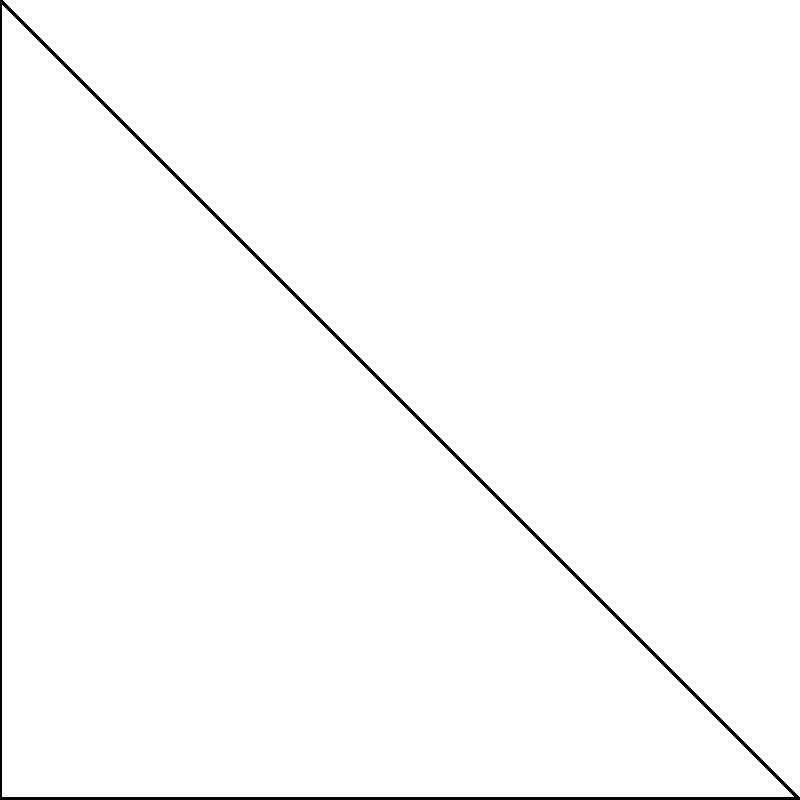In your rehabilitation program, you're analyzing different swimming strokes and their impact on your shoulder. Consider two paths from point A to point C: a straight line on a flat plane (representing a direct arm movement) and an arc on a curved surface (representing a more natural, rounded arm movement). If the straight-line distance between A and C is 30 cm, and the arc length is 1.2 times the straight-line distance, what is the difference in distance between these two paths? Let's approach this step-by-step:

1) First, we know the straight-line distance (on the flat plane) from A to C:
   $AC_{flat} = 30$ cm

2) The arc length (on the curved surface) is given as 1.2 times the straight-line distance:
   $AC_{curved} = 1.2 \times AC_{flat}$

3) Let's calculate the arc length:
   $AC_{curved} = 1.2 \times 30 = 36$ cm

4) Now, to find the difference in distance, we subtract the straight-line distance from the arc length:
   $Difference = AC_{curved} - AC_{flat}$
   $Difference = 36 - 30 = 6$ cm

This difference represents how much farther your arm travels in the more natural, rounded movement compared to a direct, straight-line movement. Understanding this difference can help in designing exercises that gradually increase the range of motion during your shoulder rehabilitation.
Answer: 6 cm 